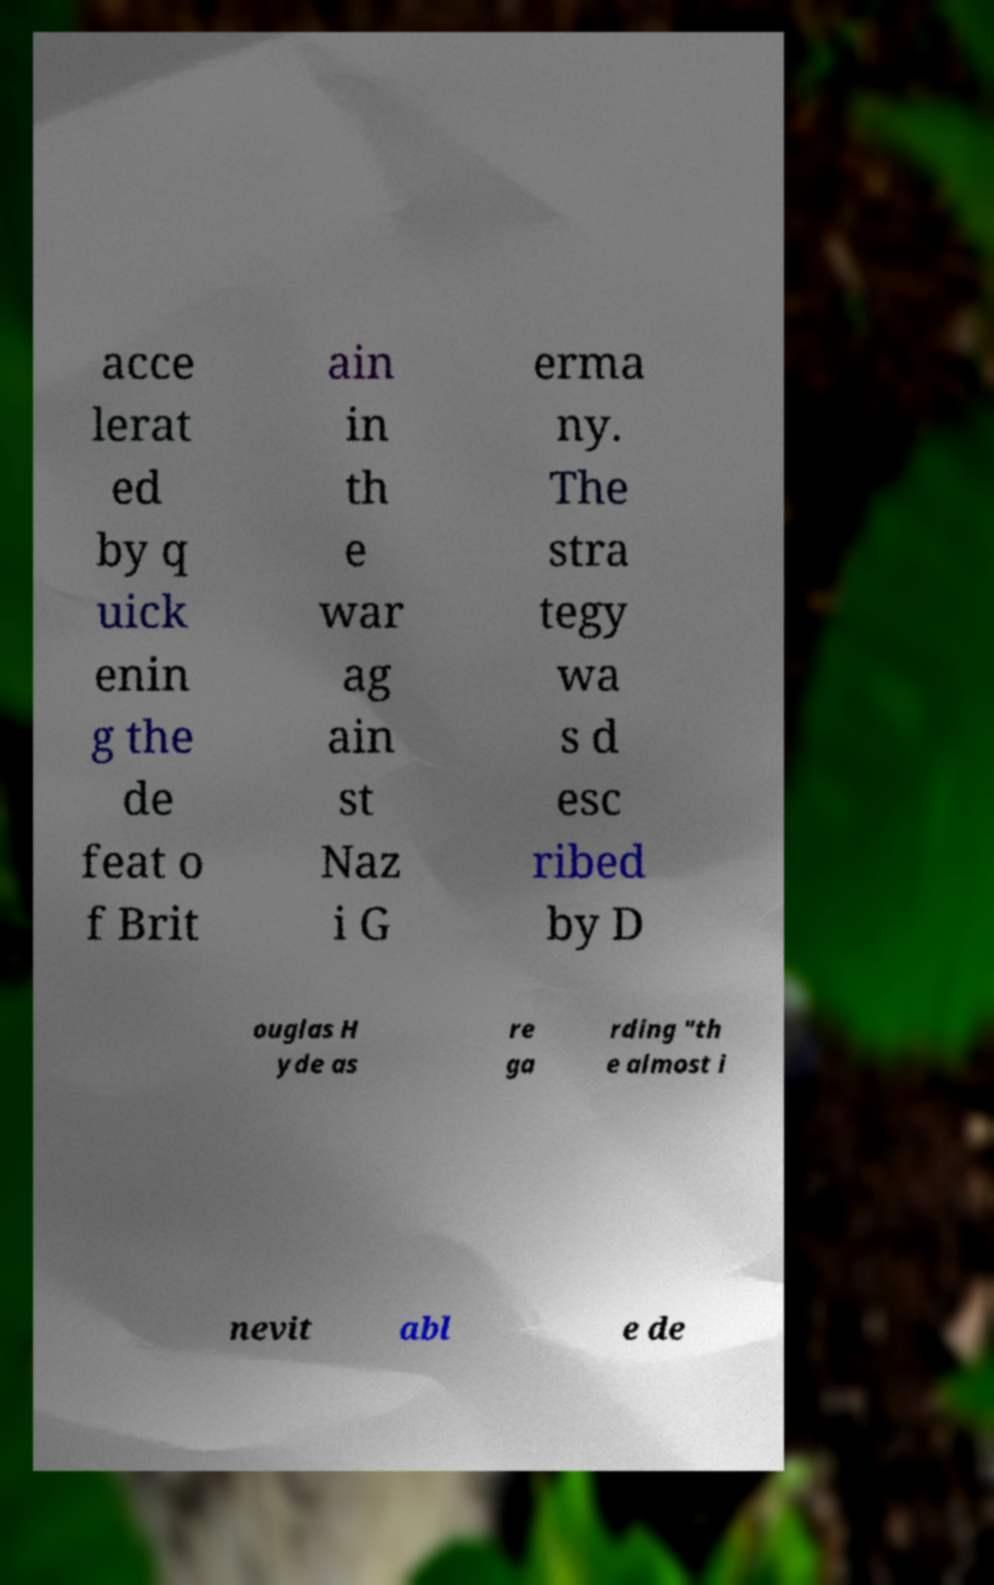For documentation purposes, I need the text within this image transcribed. Could you provide that? acce lerat ed by q uick enin g the de feat o f Brit ain in th e war ag ain st Naz i G erma ny. The stra tegy wa s d esc ribed by D ouglas H yde as re ga rding "th e almost i nevit abl e de 